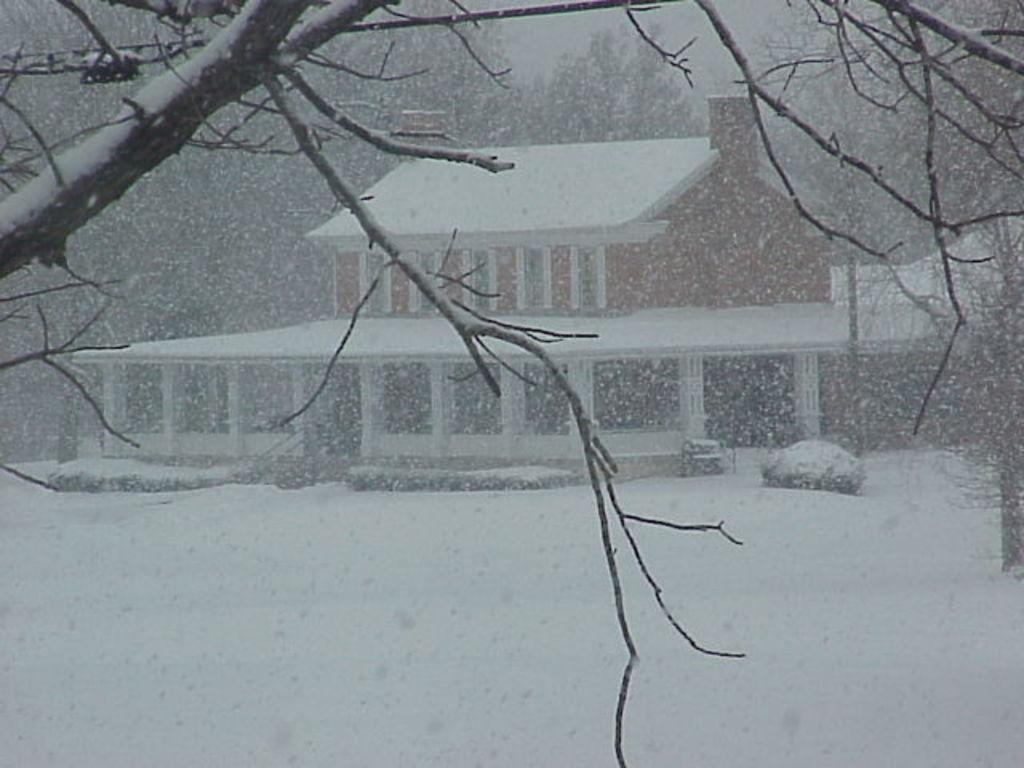What type of structure is present in the image? There is a house in the picture. What features can be observed on the house? The house has windows and pillars. What other elements are present in the image? There are trees, a vehicle, snow, and some unspecified objects in the picture. What type of cap is the tooth wearing during the dinner in the image? There is no cap, tooth, or dinner present in the image. 